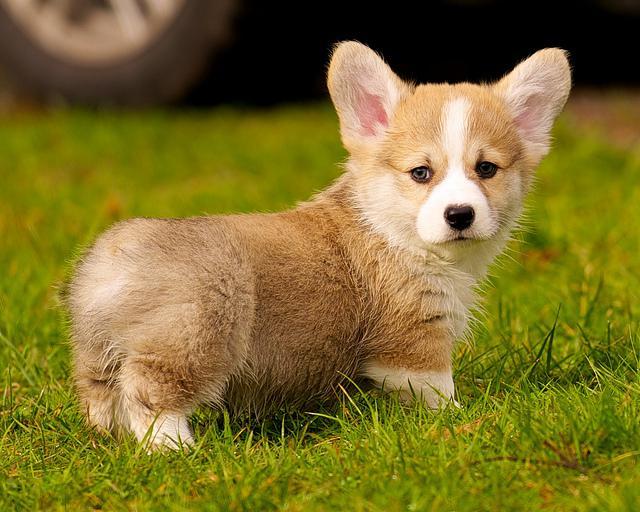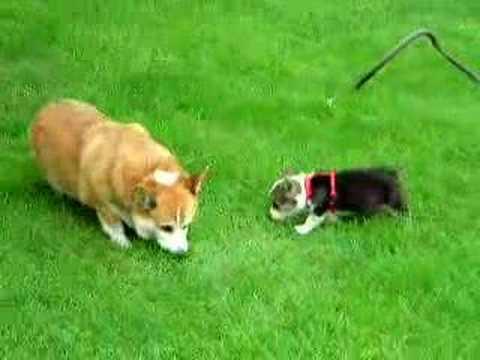The first image is the image on the left, the second image is the image on the right. For the images shown, is this caption "There are 3 dogs outdoors on the grass." true? Answer yes or no. Yes. The first image is the image on the left, the second image is the image on the right. Assess this claim about the two images: "Three dogs are visible.". Correct or not? Answer yes or no. Yes. 